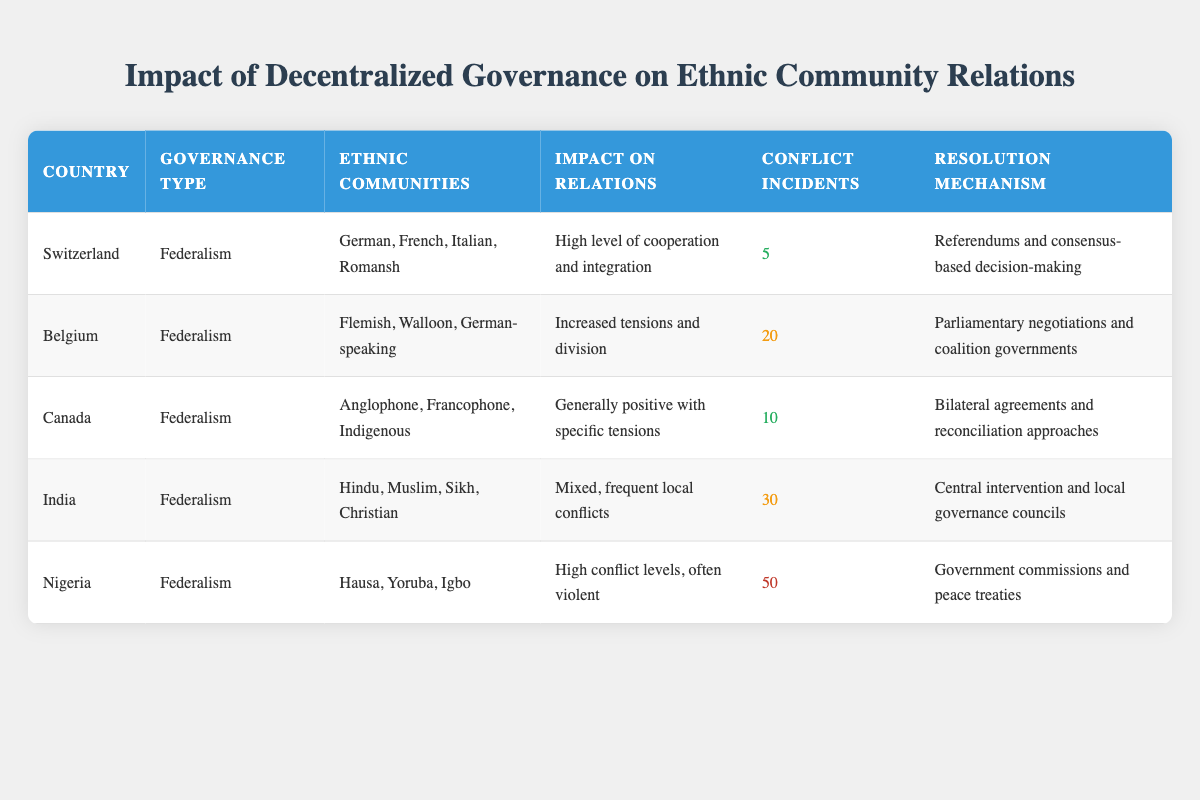What is the impact on relations in Switzerland? According to the table, Switzerland has a high level of cooperation and integration as the impact on relations. This information is directly listed under the "Impact on Relations" column for Switzerland.
Answer: High level of cooperation and integration How many ethnic communities are there in Canada? The table indicates that Canada has three ethnic communities: Anglophone, Francophone, and Indigenous. This is directly stated in the "Ethnic Communities" column for Canada.
Answer: 3 Which country has the highest number of conflict incidents? By reviewing the "Conflict Incidents" column, Nigeria shows the highest number of incidents with a total of 50. This is compared to other countries listed in the table.
Answer: Nigeria What is the average number of conflict incidents among all countries? Adding the conflict incidents (5 + 20 + 10 + 30 + 50) gives a total of 115 incidents. There are 5 countries, so the average is 115 divided by 5, which equals 23.
Answer: 23 Is the impact on community relations in Belgium more positive than in Canada? The table indicates that Belgium has increased tensions and division, while Canada has a generally positive impact with specific tensions. Since positive relations are better than increased tensions, the answer is no.
Answer: No Which country uses referendums as a resolution mechanism? According to the table, Switzerland utilizes referendums and consensus-based decision-making as their resolution mechanism. This is found in the "Resolution Mechanism" column for Switzerland.
Answer: Switzerland How many countries have a mixed impact on relations according to the table? Inspecting the impact descriptions, only India is labeled with a mixed impact on relations. Each country's impact was analyzed, and only India fits this description.
Answer: 1 What type of decentralized governance does Nigeria utilize? The table specifies that Nigeria employs a federalism governance type, as indicated in the "Decentralized Governance Type" column.
Answer: Federalism Which country among those listed experiences a high level of violence in conflict incidents? Referring to the "Impact on Relations" column, Nigeria is noted for high conflict levels, often violent. This suggests the significant nature of the conflicts in Nigeria.
Answer: Nigeria 